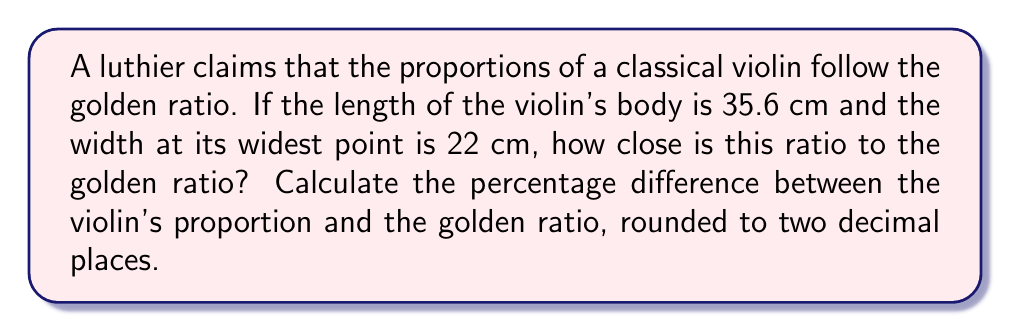Can you solve this math problem? Let's approach this step-by-step:

1) The golden ratio, denoted by $\phi$, is approximately equal to:
   $$\phi = \frac{1 + \sqrt{5}}{2} \approx 1.61803398875$$

2) The ratio of the violin's length to its width is:
   $$\frac{\text{length}}{\text{width}} = \frac{35.6}{22} \approx 1.61818181818$$

3) To calculate the percentage difference, we use the formula:
   $$\text{Percentage Difference} = \left|\frac{\text{Observed Value} - \text{Expected Value}}{\text{Expected Value}}\right| \times 100\%$$

4) Plugging in our values:
   $$\text{Percentage Difference} = \left|\frac{1.61818181818 - 1.61803398875}{1.61803398875}\right| \times 100\%$$

5) Calculating:
   $$\text{Percentage Difference} = 0.0000917 \times 100\% = 0.00917\%$$

6) Rounding to two decimal places:
   $$\text{Percentage Difference} \approx 0.01\%$$

This incredibly small difference suggests that the luthier's claim about the violin's proportions following the golden ratio is remarkably accurate, perhaps more so than one might expect from a handcrafted instrument. This precision might appeal to a classical musician's appreciation for mathematical harmony in music, while also potentially challenging their skepticism about claims made on the internet.
Answer: 0.01% 